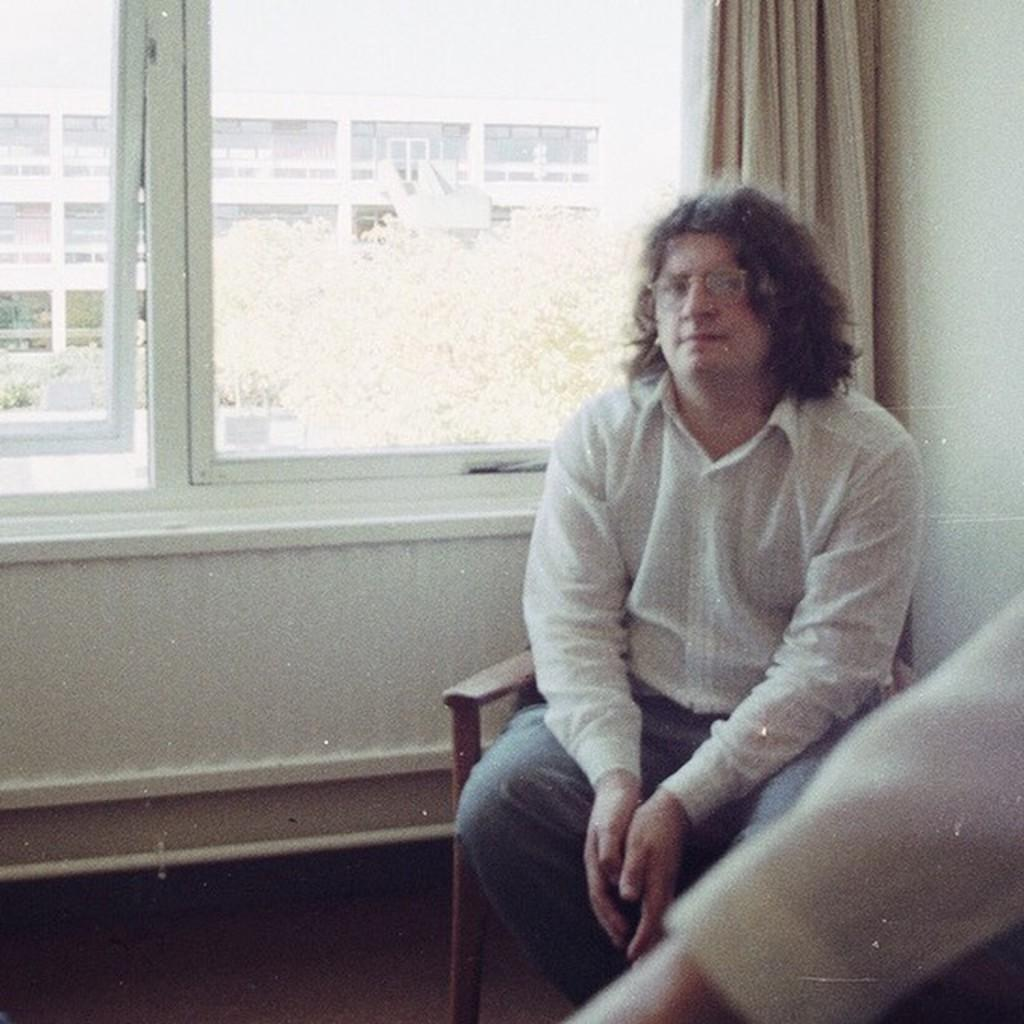What is the person in the image doing? There is a person sitting on a chair in the image. What can be seen in the background of the image? There is a wall, windows, a curtain, trees, and a building visible in the background of the image. What type of slave is depicted in the image? There is no slave present in the image; it features a person sitting on a chair. What decisions were made by the committee in the image? There is no committee present in the image, so no decisions can be made. 